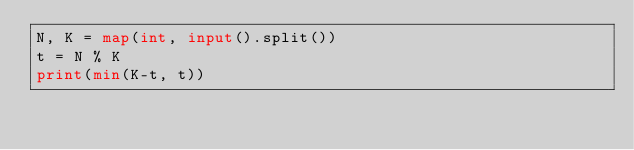Convert code to text. <code><loc_0><loc_0><loc_500><loc_500><_Python_>N, K = map(int, input().split())
t = N % K
print(min(K-t, t))</code> 